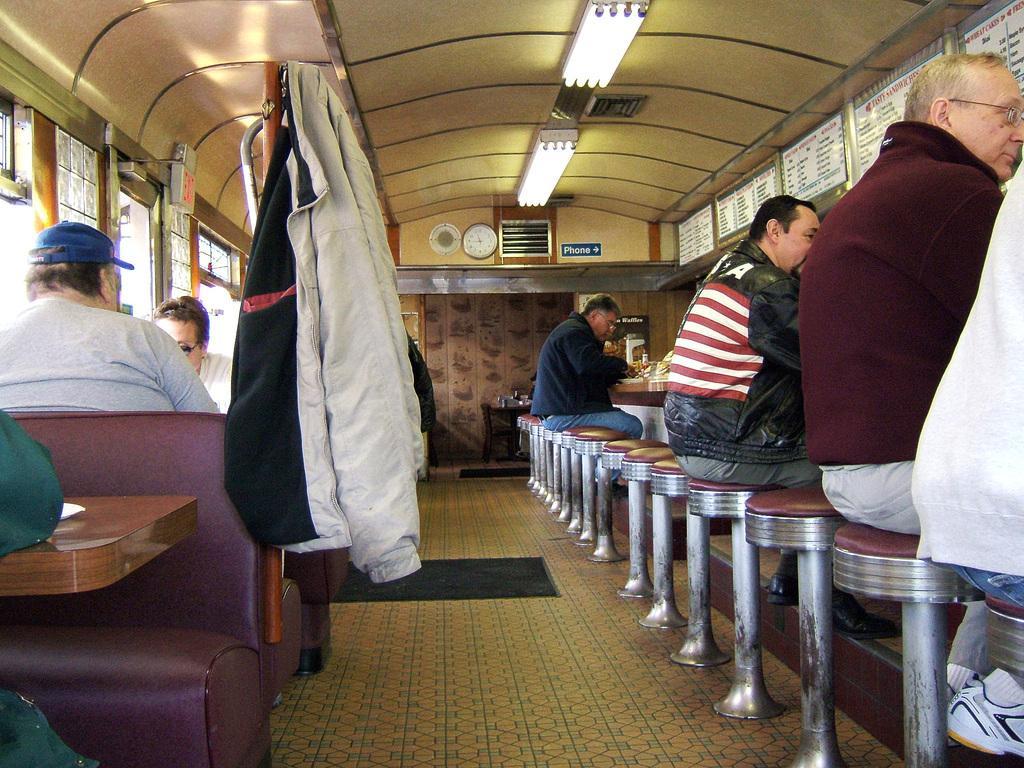In one or two sentences, can you explain what this image depicts? In this image I see number of people sitting on chairs and there are tables in front of them and I can also see that there is a menu board over here and there lights on the ceiling. 